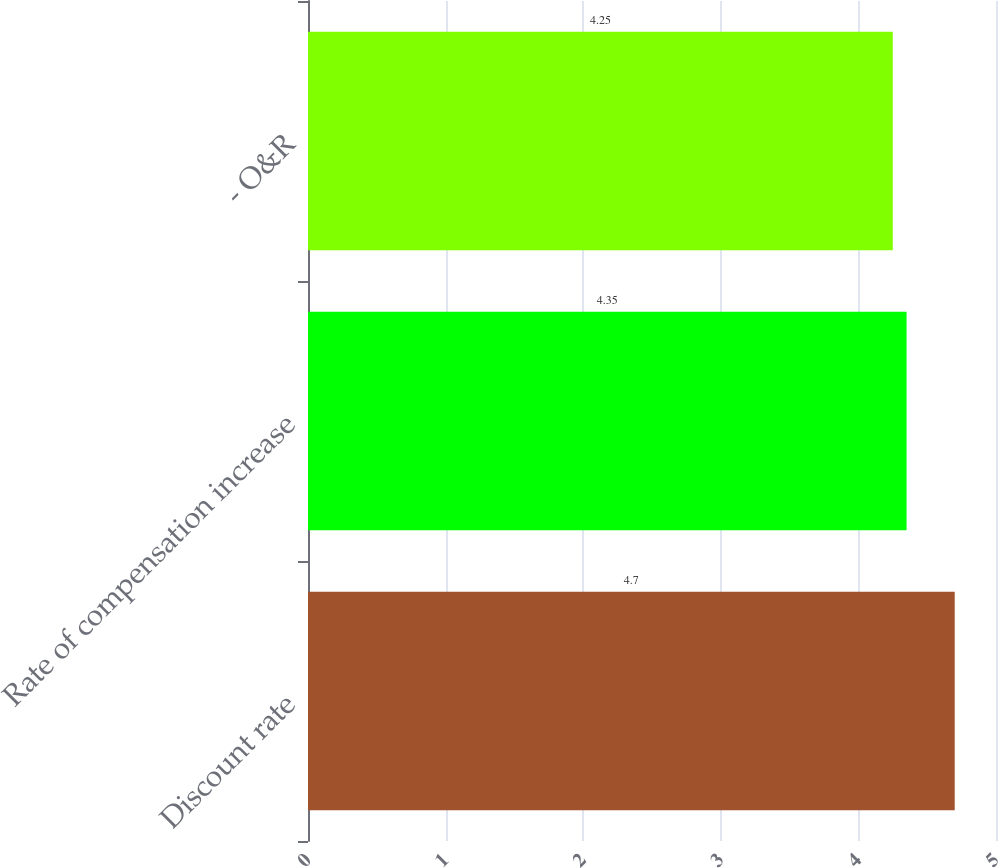Convert chart. <chart><loc_0><loc_0><loc_500><loc_500><bar_chart><fcel>Discount rate<fcel>Rate of compensation increase<fcel>- O&R<nl><fcel>4.7<fcel>4.35<fcel>4.25<nl></chart> 